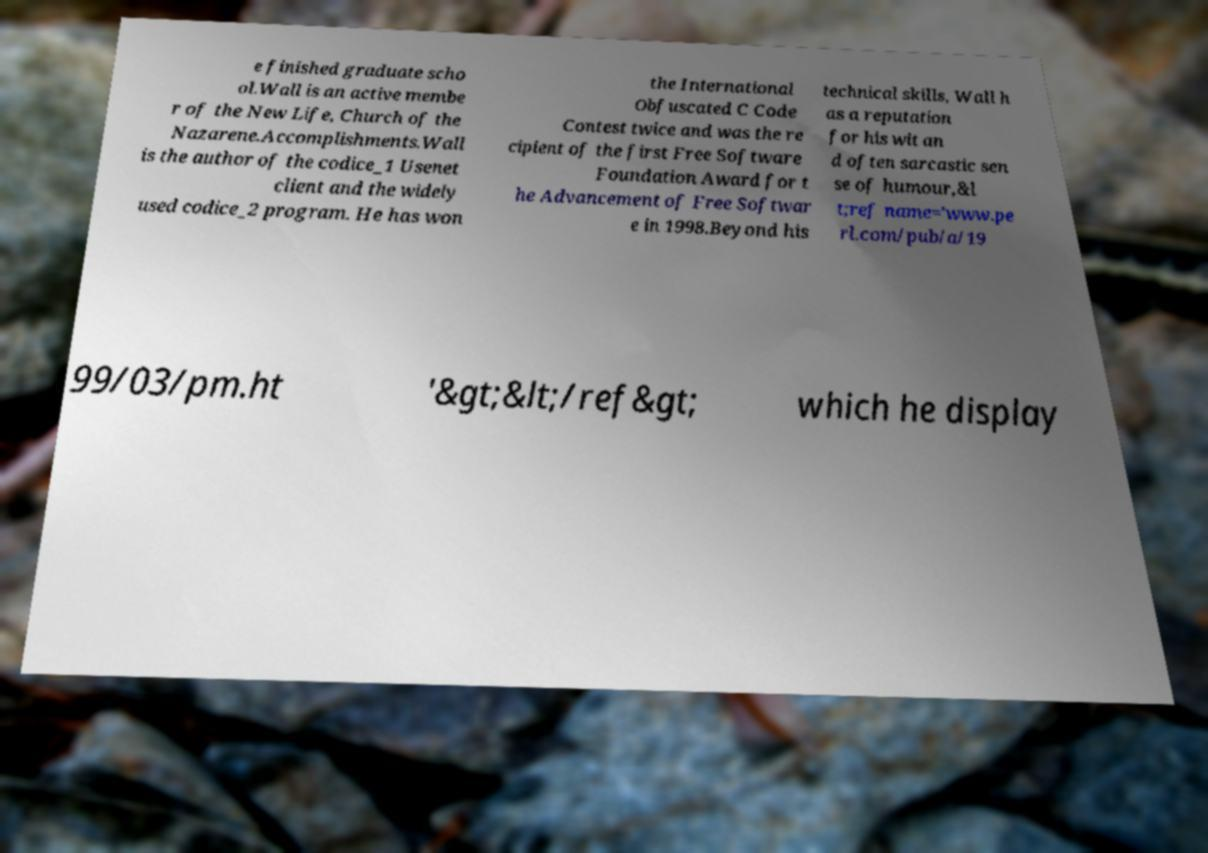Please identify and transcribe the text found in this image. e finished graduate scho ol.Wall is an active membe r of the New Life, Church of the Nazarene.Accomplishments.Wall is the author of the codice_1 Usenet client and the widely used codice_2 program. He has won the International Obfuscated C Code Contest twice and was the re cipient of the first Free Software Foundation Award for t he Advancement of Free Softwar e in 1998.Beyond his technical skills, Wall h as a reputation for his wit an d often sarcastic sen se of humour,&l t;ref name='www.pe rl.com/pub/a/19 99/03/pm.ht '&gt;&lt;/ref&gt; which he display 